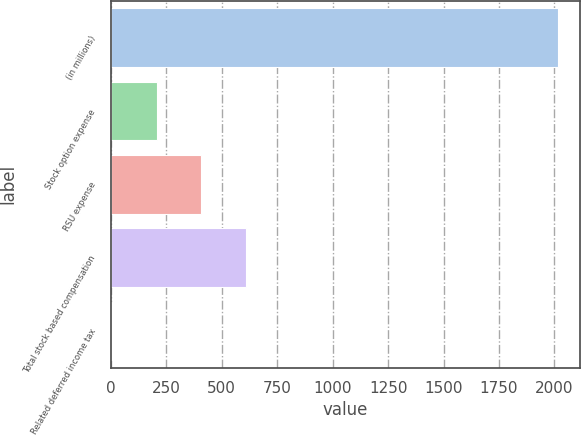Convert chart. <chart><loc_0><loc_0><loc_500><loc_500><bar_chart><fcel>(in millions)<fcel>Stock option expense<fcel>RSU expense<fcel>Total stock based compensation<fcel>Related deferred income tax<nl><fcel>2014<fcel>207.43<fcel>408.16<fcel>608.89<fcel>6.7<nl></chart> 